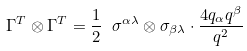Convert formula to latex. <formula><loc_0><loc_0><loc_500><loc_500>\Gamma ^ { T } \otimes \Gamma ^ { T } = \frac { 1 } { 2 } \ \sigma ^ { \alpha \lambda } \otimes \sigma _ { \beta \lambda } \cdot \frac { 4 q _ { \alpha } q ^ { \beta } } { q ^ { 2 } }</formula> 